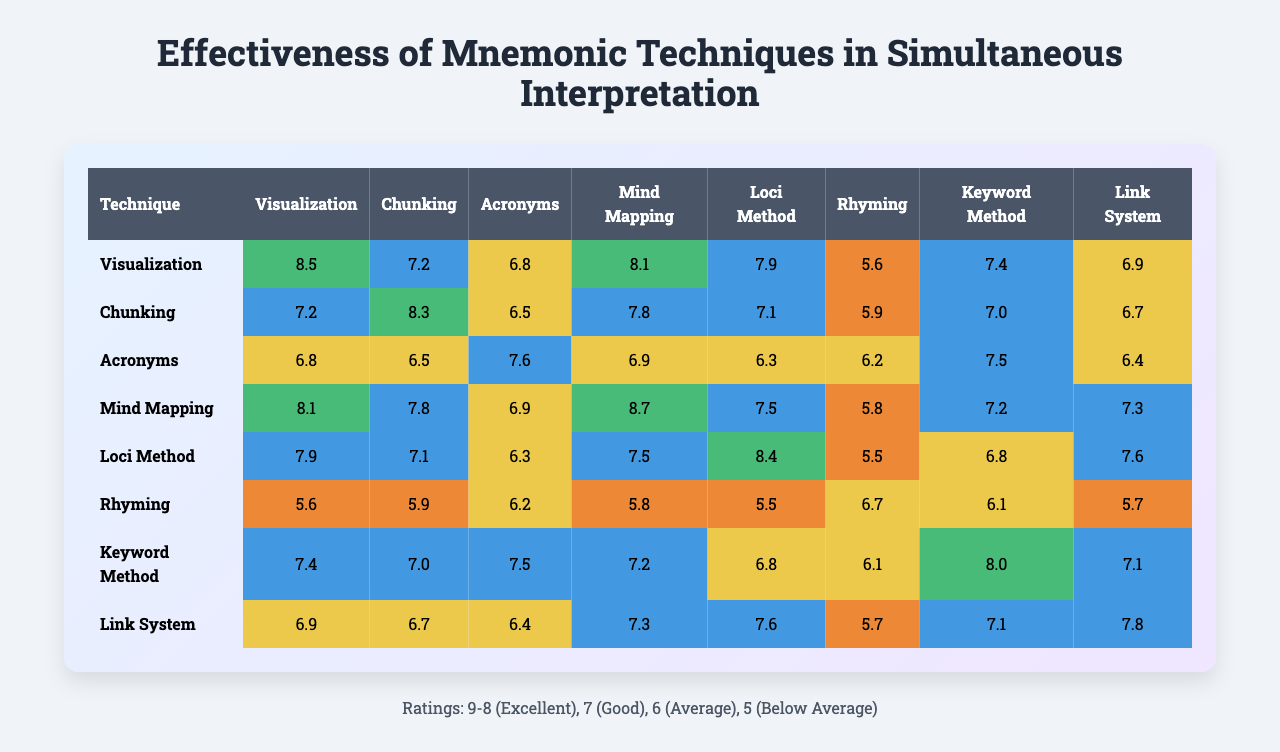What is the effectiveness rating for the Loci Method? The effectiveness rating for the Loci Method can be found in the row corresponding to the Loci Method in the table. The ratings are [7.9, 7.1, 6.3, 7.5, 8.4, 5.5, 6.8, 7.6]. The highest rating here is 8.4.
Answer: 8.4 Which technique has the highest average effectiveness rating? To find the technique with the highest average effectiveness rating, we need to calculate the average for each technique. For example, Visualization's average is (8.5 + 7.2 + 6.8 + 8.1 + 7.9 + 5.6 + 7.4 + 6.9) / 8 = 7.5. After calculating the averages for all techniques, Visualization has the highest average at 7.5.
Answer: Visualization Is the effectiveness rating for Chunking better than that of Rhyming? We compare the effectiveness ratings for Chunking and Rhyming. Chunking’s rating varies between [7.2, 8.3, 6.5, 7.8, 7.1, 5.9, 7.0, 6.7] and Rhyming’s ratings are [5.6, 5.9, 6.2, 5.8, 5.5, 6.7, 6.1, 5.7]. Since the highest rating for Chunking is 8.3 compared to Rhyming's highest of 6.7, Chunking has a better effectiveness rating.
Answer: Yes What is the sum of the effectiveness ratings for the Keyword Method? To find the sum for the Keyword Method, look at the row for the Keyword Method: [7.4, 7.0, 7.5, 7.2, 6.8, 6.1, 8.0, 7.1]. By adding these values together: 7.4 + 7.0 + 7.5 + 7.2 + 6.8 + 6.1 + 8.0 + 7.1 = 59.2.
Answer: 59.2 Which techniques have ratings lower than 6? We review each technique’s ratings to identify any that are lower than 6. Rhyming has ratings such as [5.6, 5.9, 5.5, 5.7], which includes values under 6. Additionally, the Loci Method also has a rating of 5.5. Thus, Rhyming and Loci Method have ratings lower than 6.
Answer: Rhyming, Loci Method What is the median effectiveness rating for Mind Mapping? The effectiveness ratings for Mind Mapping are [8.1, 7.8, 6.9, 8.7, 7.5, 5.8, 7.2, 7.3]. To find the median, sort these values: [5.8, 6.9, 7.2, 7.3, 7.5, 7.8, 8.1, 8.7]. Since there are 8 values, the median will be the average of the 4th and 5th values, which are 7.3 and 7.5. Therefore, (7.3 + 7.5) / 2 = 7.4.
Answer: 7.4 Which technique shows the most variation in effectiveness ratings? To assess variability, we need to look at the range of ratings for each technique. The technique with the largest difference between the highest and lowest rating indicates greater variability. For instance, Rhyming has a range of 5.6 - 5.5 indicating low variation, whereas the Loci Method has a range of 8.4 - 5.5, suggesting it has more variation.
Answer: Loci Method 